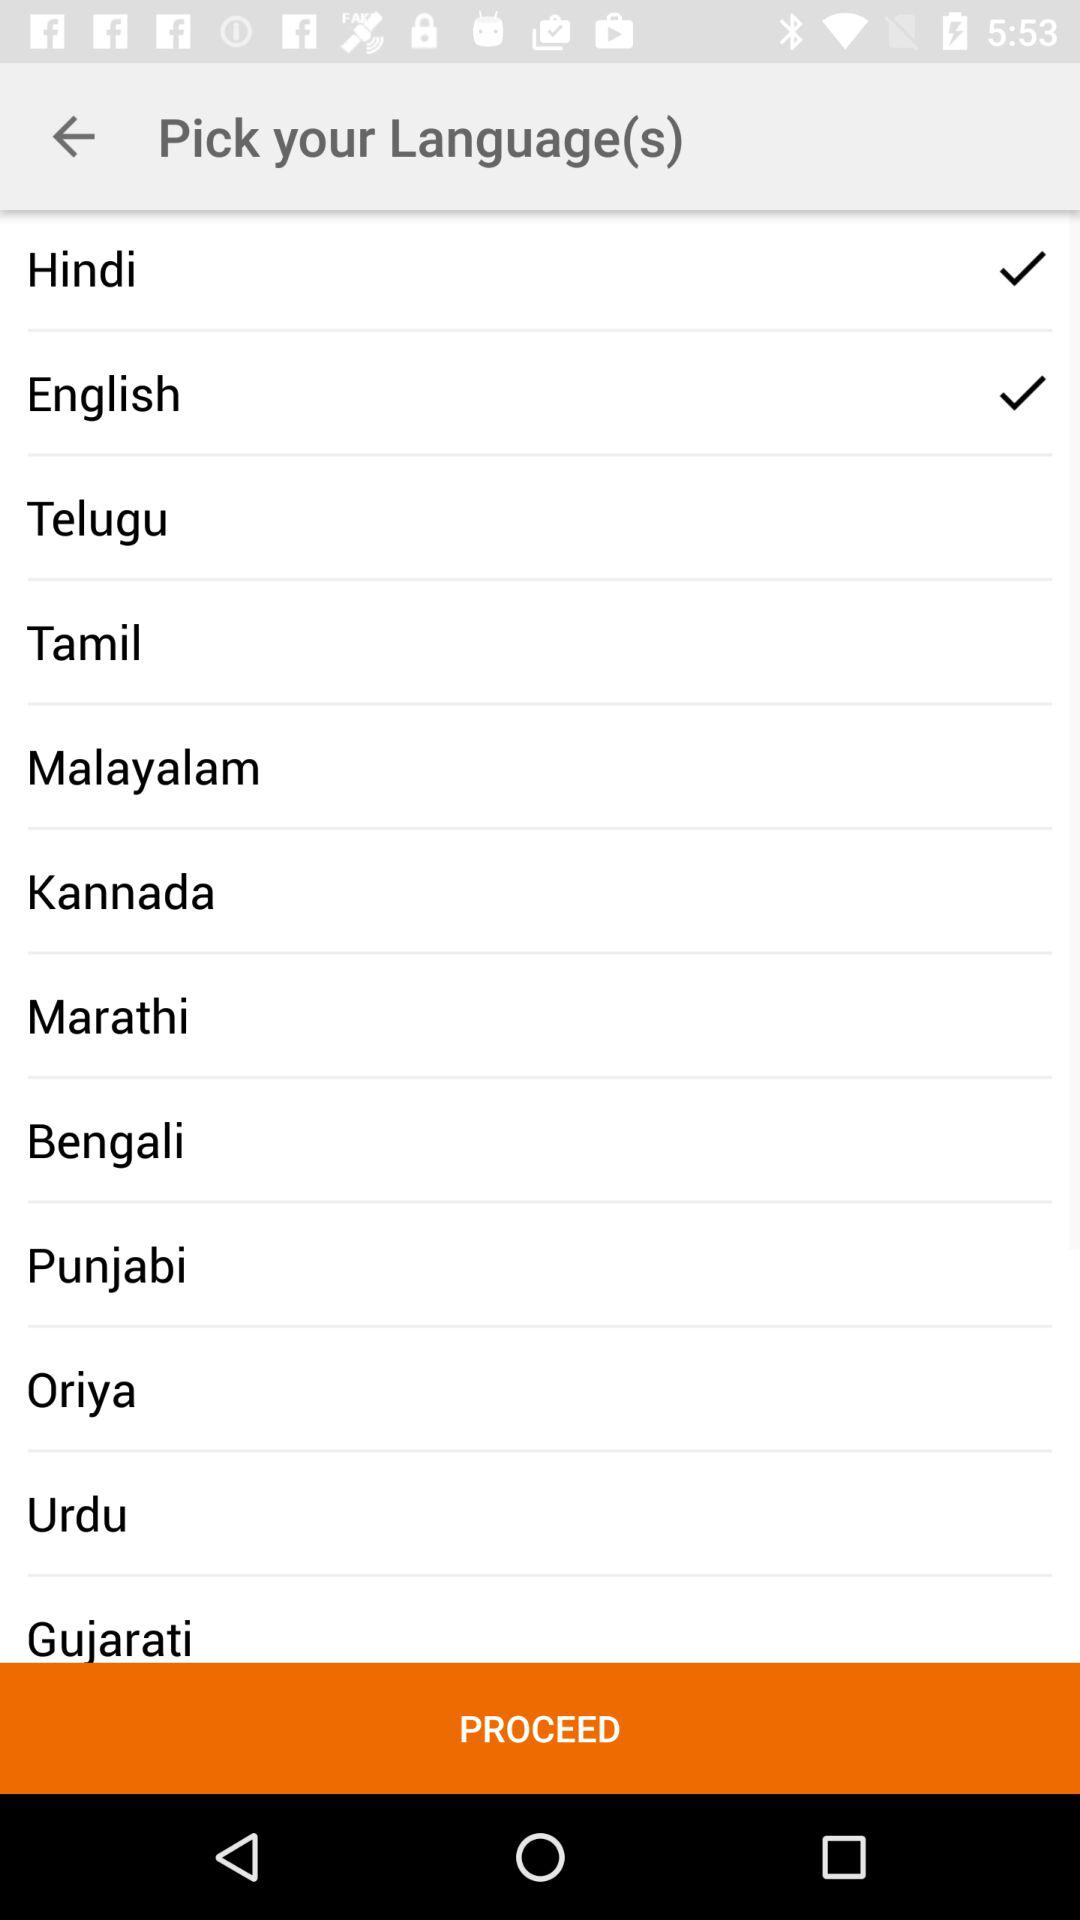Which option was selected? The selected options were "Hindi" and "English". 